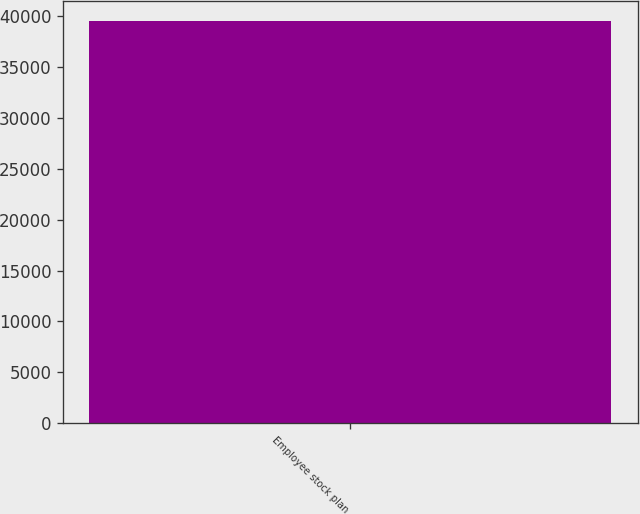Convert chart. <chart><loc_0><loc_0><loc_500><loc_500><bar_chart><fcel>Employee stock plan<nl><fcel>39537<nl></chart> 